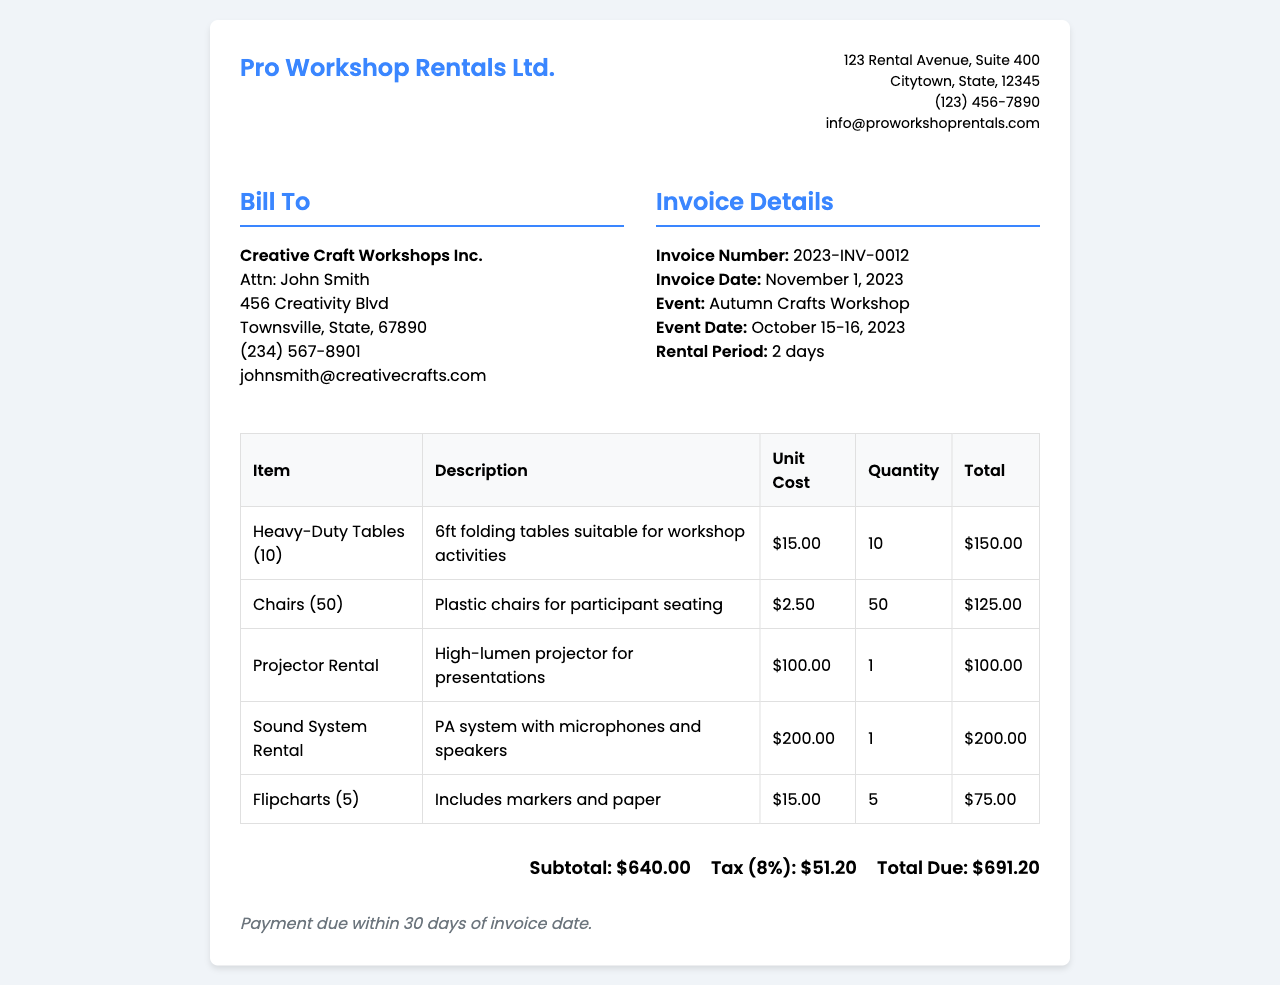What is the invoice number? The invoice number is provided in the invoice details section.
Answer: 2023-INV-0012 What is the total amount due? The total amount due is calculated by adding the subtotal and tax.
Answer: $691.20 Who is the client? The client information is listed under the "Bill To" section.
Answer: Creative Craft Workshops Inc What are the event dates? The event dates are mentioned in the event information section.
Answer: October 15-16, 2023 How many heavy-duty tables were rented? The quantity of heavy-duty tables is specified in the itemized list.
Answer: 10 What is the tax rate applied on the invoice? The tax rate is provided in the total section as a percentage.
Answer: 8% What item has the highest rental cost? The rental costs of all items are listed; the highest is identified.
Answer: Sound System Rental What is the subtotal of all rentals? The subtotal is provided before tax is added to the total.
Answer: $640.00 What are the payment terms specified in the invoice? The payment terms are stated at the end of the invoice.
Answer: Payment due within 30 days of invoice date 